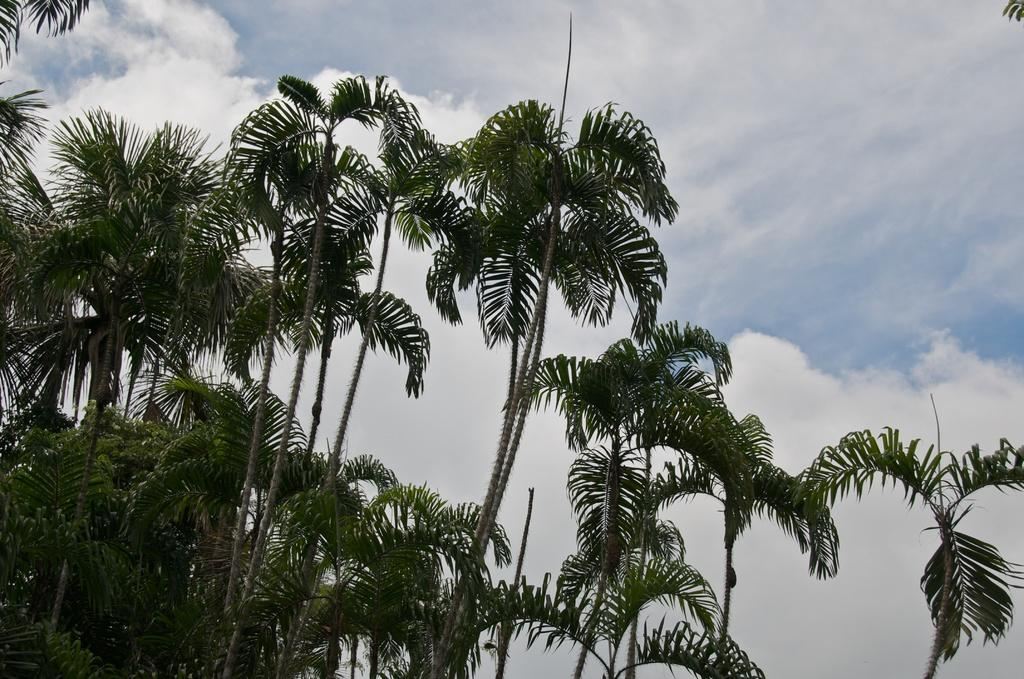What type of vegetation can be seen in the image? There are trees in the image. What is visible in the background of the image? The sky is visible in the background of the image. Can you describe the sky in the image? The sky appears to be cloudy in the image. What type of quartz can be seen in the image? There is no quartz present in the image. Is there a tiger visible in the image? No, there is no tiger present in the image. 